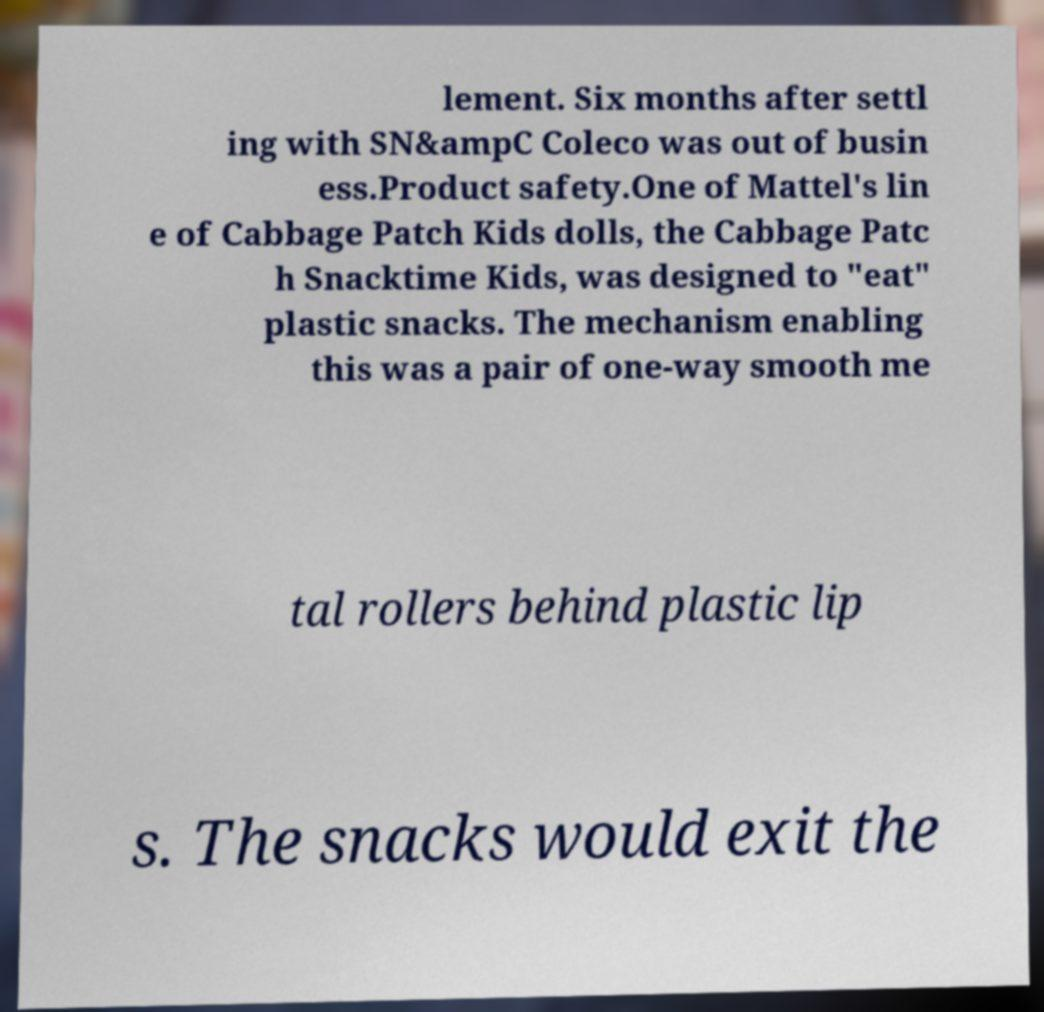Can you accurately transcribe the text from the provided image for me? lement. Six months after settl ing with SN&ampC Coleco was out of busin ess.Product safety.One of Mattel's lin e of Cabbage Patch Kids dolls, the Cabbage Patc h Snacktime Kids, was designed to "eat" plastic snacks. The mechanism enabling this was a pair of one-way smooth me tal rollers behind plastic lip s. The snacks would exit the 